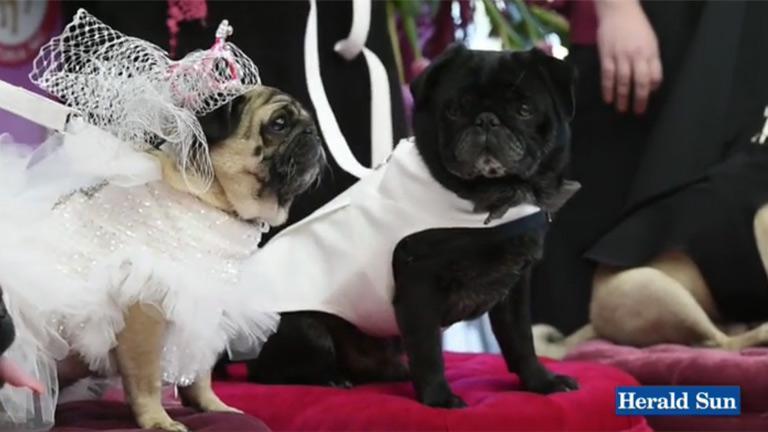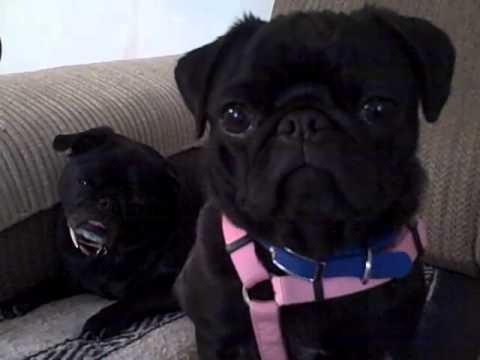The first image is the image on the left, the second image is the image on the right. Given the left and right images, does the statement "At least one of the dogs is wearing something around its neck." hold true? Answer yes or no. Yes. 